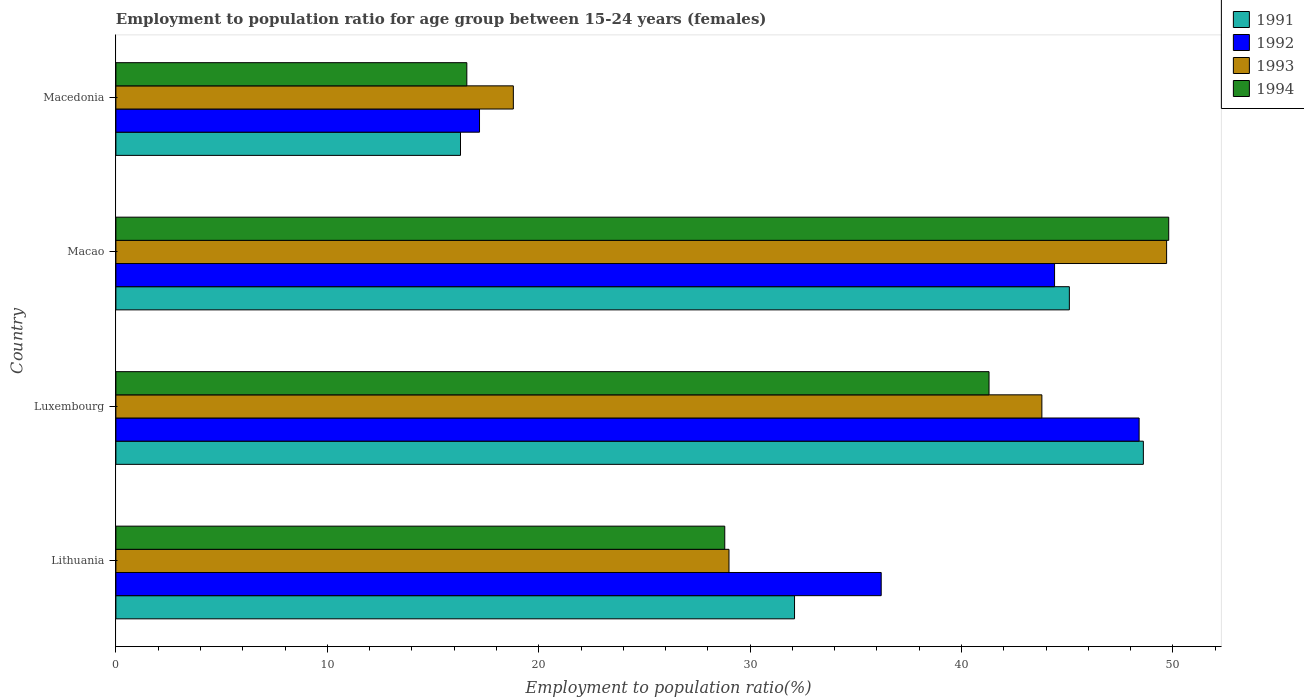How many different coloured bars are there?
Your answer should be very brief. 4. How many groups of bars are there?
Keep it short and to the point. 4. What is the label of the 4th group of bars from the top?
Your answer should be compact. Lithuania. In how many cases, is the number of bars for a given country not equal to the number of legend labels?
Make the answer very short. 0. What is the employment to population ratio in 1993 in Luxembourg?
Make the answer very short. 43.8. Across all countries, what is the maximum employment to population ratio in 1991?
Offer a terse response. 48.6. Across all countries, what is the minimum employment to population ratio in 1994?
Your response must be concise. 16.6. In which country was the employment to population ratio in 1991 maximum?
Your response must be concise. Luxembourg. In which country was the employment to population ratio in 1992 minimum?
Provide a short and direct response. Macedonia. What is the total employment to population ratio in 1991 in the graph?
Your response must be concise. 142.1. What is the difference between the employment to population ratio in 1992 in Lithuania and that in Luxembourg?
Ensure brevity in your answer.  -12.2. What is the difference between the employment to population ratio in 1993 in Luxembourg and the employment to population ratio in 1991 in Lithuania?
Your response must be concise. 11.7. What is the average employment to population ratio in 1993 per country?
Your answer should be compact. 35.32. What is the difference between the employment to population ratio in 1993 and employment to population ratio in 1992 in Luxembourg?
Your answer should be compact. -4.6. What is the ratio of the employment to population ratio in 1993 in Lithuania to that in Luxembourg?
Your answer should be compact. 0.66. What is the difference between the highest and the lowest employment to population ratio in 1992?
Offer a terse response. 31.2. In how many countries, is the employment to population ratio in 1992 greater than the average employment to population ratio in 1992 taken over all countries?
Keep it short and to the point. 2. Is the sum of the employment to population ratio in 1992 in Luxembourg and Macedonia greater than the maximum employment to population ratio in 1994 across all countries?
Offer a terse response. Yes. What does the 4th bar from the top in Macedonia represents?
Keep it short and to the point. 1991. What does the 4th bar from the bottom in Macao represents?
Provide a short and direct response. 1994. What is the difference between two consecutive major ticks on the X-axis?
Your response must be concise. 10. Does the graph contain grids?
Keep it short and to the point. No. Where does the legend appear in the graph?
Make the answer very short. Top right. What is the title of the graph?
Offer a very short reply. Employment to population ratio for age group between 15-24 years (females). What is the Employment to population ratio(%) of 1991 in Lithuania?
Give a very brief answer. 32.1. What is the Employment to population ratio(%) in 1992 in Lithuania?
Keep it short and to the point. 36.2. What is the Employment to population ratio(%) of 1993 in Lithuania?
Offer a terse response. 29. What is the Employment to population ratio(%) in 1994 in Lithuania?
Your answer should be compact. 28.8. What is the Employment to population ratio(%) of 1991 in Luxembourg?
Make the answer very short. 48.6. What is the Employment to population ratio(%) of 1992 in Luxembourg?
Your response must be concise. 48.4. What is the Employment to population ratio(%) of 1993 in Luxembourg?
Your answer should be very brief. 43.8. What is the Employment to population ratio(%) of 1994 in Luxembourg?
Provide a short and direct response. 41.3. What is the Employment to population ratio(%) in 1991 in Macao?
Offer a very short reply. 45.1. What is the Employment to population ratio(%) of 1992 in Macao?
Your answer should be very brief. 44.4. What is the Employment to population ratio(%) of 1993 in Macao?
Your answer should be compact. 49.7. What is the Employment to population ratio(%) of 1994 in Macao?
Give a very brief answer. 49.8. What is the Employment to population ratio(%) of 1991 in Macedonia?
Provide a succinct answer. 16.3. What is the Employment to population ratio(%) in 1992 in Macedonia?
Your answer should be compact. 17.2. What is the Employment to population ratio(%) in 1993 in Macedonia?
Your answer should be compact. 18.8. What is the Employment to population ratio(%) of 1994 in Macedonia?
Your response must be concise. 16.6. Across all countries, what is the maximum Employment to population ratio(%) of 1991?
Your answer should be very brief. 48.6. Across all countries, what is the maximum Employment to population ratio(%) of 1992?
Your answer should be compact. 48.4. Across all countries, what is the maximum Employment to population ratio(%) of 1993?
Keep it short and to the point. 49.7. Across all countries, what is the maximum Employment to population ratio(%) of 1994?
Provide a short and direct response. 49.8. Across all countries, what is the minimum Employment to population ratio(%) of 1991?
Give a very brief answer. 16.3. Across all countries, what is the minimum Employment to population ratio(%) in 1992?
Make the answer very short. 17.2. Across all countries, what is the minimum Employment to population ratio(%) of 1993?
Provide a succinct answer. 18.8. Across all countries, what is the minimum Employment to population ratio(%) in 1994?
Make the answer very short. 16.6. What is the total Employment to population ratio(%) of 1991 in the graph?
Your answer should be compact. 142.1. What is the total Employment to population ratio(%) of 1992 in the graph?
Provide a short and direct response. 146.2. What is the total Employment to population ratio(%) in 1993 in the graph?
Offer a terse response. 141.3. What is the total Employment to population ratio(%) in 1994 in the graph?
Give a very brief answer. 136.5. What is the difference between the Employment to population ratio(%) in 1991 in Lithuania and that in Luxembourg?
Your answer should be very brief. -16.5. What is the difference between the Employment to population ratio(%) of 1993 in Lithuania and that in Luxembourg?
Offer a very short reply. -14.8. What is the difference between the Employment to population ratio(%) of 1991 in Lithuania and that in Macao?
Your answer should be compact. -13. What is the difference between the Employment to population ratio(%) of 1992 in Lithuania and that in Macao?
Your answer should be compact. -8.2. What is the difference between the Employment to population ratio(%) of 1993 in Lithuania and that in Macao?
Offer a very short reply. -20.7. What is the difference between the Employment to population ratio(%) of 1992 in Lithuania and that in Macedonia?
Offer a very short reply. 19. What is the difference between the Employment to population ratio(%) of 1991 in Luxembourg and that in Macao?
Give a very brief answer. 3.5. What is the difference between the Employment to population ratio(%) of 1993 in Luxembourg and that in Macao?
Provide a succinct answer. -5.9. What is the difference between the Employment to population ratio(%) in 1994 in Luxembourg and that in Macao?
Offer a very short reply. -8.5. What is the difference between the Employment to population ratio(%) of 1991 in Luxembourg and that in Macedonia?
Your answer should be very brief. 32.3. What is the difference between the Employment to population ratio(%) of 1992 in Luxembourg and that in Macedonia?
Provide a succinct answer. 31.2. What is the difference between the Employment to population ratio(%) of 1994 in Luxembourg and that in Macedonia?
Keep it short and to the point. 24.7. What is the difference between the Employment to population ratio(%) in 1991 in Macao and that in Macedonia?
Offer a very short reply. 28.8. What is the difference between the Employment to population ratio(%) in 1992 in Macao and that in Macedonia?
Make the answer very short. 27.2. What is the difference between the Employment to population ratio(%) of 1993 in Macao and that in Macedonia?
Keep it short and to the point. 30.9. What is the difference between the Employment to population ratio(%) in 1994 in Macao and that in Macedonia?
Keep it short and to the point. 33.2. What is the difference between the Employment to population ratio(%) in 1991 in Lithuania and the Employment to population ratio(%) in 1992 in Luxembourg?
Offer a terse response. -16.3. What is the difference between the Employment to population ratio(%) in 1991 in Lithuania and the Employment to population ratio(%) in 1994 in Luxembourg?
Your answer should be compact. -9.2. What is the difference between the Employment to population ratio(%) in 1992 in Lithuania and the Employment to population ratio(%) in 1994 in Luxembourg?
Your response must be concise. -5.1. What is the difference between the Employment to population ratio(%) in 1993 in Lithuania and the Employment to population ratio(%) in 1994 in Luxembourg?
Your answer should be very brief. -12.3. What is the difference between the Employment to population ratio(%) in 1991 in Lithuania and the Employment to population ratio(%) in 1992 in Macao?
Your answer should be very brief. -12.3. What is the difference between the Employment to population ratio(%) of 1991 in Lithuania and the Employment to population ratio(%) of 1993 in Macao?
Offer a terse response. -17.6. What is the difference between the Employment to population ratio(%) in 1991 in Lithuania and the Employment to population ratio(%) in 1994 in Macao?
Your answer should be compact. -17.7. What is the difference between the Employment to population ratio(%) of 1992 in Lithuania and the Employment to population ratio(%) of 1993 in Macao?
Provide a succinct answer. -13.5. What is the difference between the Employment to population ratio(%) of 1993 in Lithuania and the Employment to population ratio(%) of 1994 in Macao?
Ensure brevity in your answer.  -20.8. What is the difference between the Employment to population ratio(%) in 1991 in Lithuania and the Employment to population ratio(%) in 1992 in Macedonia?
Ensure brevity in your answer.  14.9. What is the difference between the Employment to population ratio(%) in 1991 in Lithuania and the Employment to population ratio(%) in 1994 in Macedonia?
Keep it short and to the point. 15.5. What is the difference between the Employment to population ratio(%) of 1992 in Lithuania and the Employment to population ratio(%) of 1994 in Macedonia?
Your response must be concise. 19.6. What is the difference between the Employment to population ratio(%) of 1993 in Lithuania and the Employment to population ratio(%) of 1994 in Macedonia?
Make the answer very short. 12.4. What is the difference between the Employment to population ratio(%) in 1991 in Luxembourg and the Employment to population ratio(%) in 1992 in Macao?
Offer a terse response. 4.2. What is the difference between the Employment to population ratio(%) in 1991 in Luxembourg and the Employment to population ratio(%) in 1994 in Macao?
Offer a terse response. -1.2. What is the difference between the Employment to population ratio(%) of 1992 in Luxembourg and the Employment to population ratio(%) of 1993 in Macao?
Keep it short and to the point. -1.3. What is the difference between the Employment to population ratio(%) in 1992 in Luxembourg and the Employment to population ratio(%) in 1994 in Macao?
Provide a short and direct response. -1.4. What is the difference between the Employment to population ratio(%) of 1993 in Luxembourg and the Employment to population ratio(%) of 1994 in Macao?
Provide a short and direct response. -6. What is the difference between the Employment to population ratio(%) of 1991 in Luxembourg and the Employment to population ratio(%) of 1992 in Macedonia?
Your response must be concise. 31.4. What is the difference between the Employment to population ratio(%) of 1991 in Luxembourg and the Employment to population ratio(%) of 1993 in Macedonia?
Offer a very short reply. 29.8. What is the difference between the Employment to population ratio(%) in 1991 in Luxembourg and the Employment to population ratio(%) in 1994 in Macedonia?
Keep it short and to the point. 32. What is the difference between the Employment to population ratio(%) of 1992 in Luxembourg and the Employment to population ratio(%) of 1993 in Macedonia?
Keep it short and to the point. 29.6. What is the difference between the Employment to population ratio(%) in 1992 in Luxembourg and the Employment to population ratio(%) in 1994 in Macedonia?
Provide a succinct answer. 31.8. What is the difference between the Employment to population ratio(%) of 1993 in Luxembourg and the Employment to population ratio(%) of 1994 in Macedonia?
Make the answer very short. 27.2. What is the difference between the Employment to population ratio(%) in 1991 in Macao and the Employment to population ratio(%) in 1992 in Macedonia?
Make the answer very short. 27.9. What is the difference between the Employment to population ratio(%) in 1991 in Macao and the Employment to population ratio(%) in 1993 in Macedonia?
Offer a terse response. 26.3. What is the difference between the Employment to population ratio(%) in 1991 in Macao and the Employment to population ratio(%) in 1994 in Macedonia?
Your answer should be very brief. 28.5. What is the difference between the Employment to population ratio(%) in 1992 in Macao and the Employment to population ratio(%) in 1993 in Macedonia?
Offer a very short reply. 25.6. What is the difference between the Employment to population ratio(%) of 1992 in Macao and the Employment to population ratio(%) of 1994 in Macedonia?
Ensure brevity in your answer.  27.8. What is the difference between the Employment to population ratio(%) of 1993 in Macao and the Employment to population ratio(%) of 1994 in Macedonia?
Offer a terse response. 33.1. What is the average Employment to population ratio(%) in 1991 per country?
Your answer should be compact. 35.52. What is the average Employment to population ratio(%) of 1992 per country?
Your answer should be very brief. 36.55. What is the average Employment to population ratio(%) of 1993 per country?
Your answer should be compact. 35.33. What is the average Employment to population ratio(%) of 1994 per country?
Your answer should be very brief. 34.12. What is the difference between the Employment to population ratio(%) of 1991 and Employment to population ratio(%) of 1993 in Lithuania?
Give a very brief answer. 3.1. What is the difference between the Employment to population ratio(%) of 1992 and Employment to population ratio(%) of 1994 in Lithuania?
Give a very brief answer. 7.4. What is the difference between the Employment to population ratio(%) in 1991 and Employment to population ratio(%) in 1992 in Luxembourg?
Make the answer very short. 0.2. What is the difference between the Employment to population ratio(%) in 1991 and Employment to population ratio(%) in 1994 in Luxembourg?
Provide a succinct answer. 7.3. What is the difference between the Employment to population ratio(%) of 1992 and Employment to population ratio(%) of 1993 in Luxembourg?
Your answer should be compact. 4.6. What is the difference between the Employment to population ratio(%) of 1991 and Employment to population ratio(%) of 1993 in Macao?
Your answer should be very brief. -4.6. What is the difference between the Employment to population ratio(%) of 1992 and Employment to population ratio(%) of 1994 in Macao?
Your answer should be very brief. -5.4. What is the difference between the Employment to population ratio(%) in 1993 and Employment to population ratio(%) in 1994 in Macao?
Give a very brief answer. -0.1. What is the difference between the Employment to population ratio(%) of 1991 and Employment to population ratio(%) of 1993 in Macedonia?
Make the answer very short. -2.5. What is the difference between the Employment to population ratio(%) of 1991 and Employment to population ratio(%) of 1994 in Macedonia?
Make the answer very short. -0.3. What is the difference between the Employment to population ratio(%) in 1992 and Employment to population ratio(%) in 1993 in Macedonia?
Offer a terse response. -1.6. What is the difference between the Employment to population ratio(%) in 1992 and Employment to population ratio(%) in 1994 in Macedonia?
Offer a terse response. 0.6. What is the ratio of the Employment to population ratio(%) in 1991 in Lithuania to that in Luxembourg?
Your answer should be compact. 0.66. What is the ratio of the Employment to population ratio(%) of 1992 in Lithuania to that in Luxembourg?
Provide a short and direct response. 0.75. What is the ratio of the Employment to population ratio(%) of 1993 in Lithuania to that in Luxembourg?
Your answer should be very brief. 0.66. What is the ratio of the Employment to population ratio(%) in 1994 in Lithuania to that in Luxembourg?
Your answer should be very brief. 0.7. What is the ratio of the Employment to population ratio(%) of 1991 in Lithuania to that in Macao?
Offer a terse response. 0.71. What is the ratio of the Employment to population ratio(%) in 1992 in Lithuania to that in Macao?
Give a very brief answer. 0.82. What is the ratio of the Employment to population ratio(%) of 1993 in Lithuania to that in Macao?
Provide a short and direct response. 0.58. What is the ratio of the Employment to population ratio(%) in 1994 in Lithuania to that in Macao?
Provide a short and direct response. 0.58. What is the ratio of the Employment to population ratio(%) in 1991 in Lithuania to that in Macedonia?
Your answer should be very brief. 1.97. What is the ratio of the Employment to population ratio(%) of 1992 in Lithuania to that in Macedonia?
Your answer should be compact. 2.1. What is the ratio of the Employment to population ratio(%) of 1993 in Lithuania to that in Macedonia?
Provide a succinct answer. 1.54. What is the ratio of the Employment to population ratio(%) in 1994 in Lithuania to that in Macedonia?
Provide a succinct answer. 1.73. What is the ratio of the Employment to population ratio(%) of 1991 in Luxembourg to that in Macao?
Ensure brevity in your answer.  1.08. What is the ratio of the Employment to population ratio(%) of 1992 in Luxembourg to that in Macao?
Your response must be concise. 1.09. What is the ratio of the Employment to population ratio(%) of 1993 in Luxembourg to that in Macao?
Your answer should be compact. 0.88. What is the ratio of the Employment to population ratio(%) of 1994 in Luxembourg to that in Macao?
Provide a short and direct response. 0.83. What is the ratio of the Employment to population ratio(%) of 1991 in Luxembourg to that in Macedonia?
Your response must be concise. 2.98. What is the ratio of the Employment to population ratio(%) in 1992 in Luxembourg to that in Macedonia?
Provide a short and direct response. 2.81. What is the ratio of the Employment to population ratio(%) in 1993 in Luxembourg to that in Macedonia?
Your answer should be very brief. 2.33. What is the ratio of the Employment to population ratio(%) of 1994 in Luxembourg to that in Macedonia?
Your answer should be compact. 2.49. What is the ratio of the Employment to population ratio(%) in 1991 in Macao to that in Macedonia?
Ensure brevity in your answer.  2.77. What is the ratio of the Employment to population ratio(%) in 1992 in Macao to that in Macedonia?
Your answer should be very brief. 2.58. What is the ratio of the Employment to population ratio(%) of 1993 in Macao to that in Macedonia?
Offer a terse response. 2.64. What is the ratio of the Employment to population ratio(%) of 1994 in Macao to that in Macedonia?
Offer a very short reply. 3. What is the difference between the highest and the second highest Employment to population ratio(%) of 1991?
Offer a terse response. 3.5. What is the difference between the highest and the second highest Employment to population ratio(%) of 1993?
Offer a terse response. 5.9. What is the difference between the highest and the second highest Employment to population ratio(%) of 1994?
Provide a short and direct response. 8.5. What is the difference between the highest and the lowest Employment to population ratio(%) in 1991?
Ensure brevity in your answer.  32.3. What is the difference between the highest and the lowest Employment to population ratio(%) in 1992?
Your answer should be compact. 31.2. What is the difference between the highest and the lowest Employment to population ratio(%) of 1993?
Offer a very short reply. 30.9. What is the difference between the highest and the lowest Employment to population ratio(%) in 1994?
Your response must be concise. 33.2. 